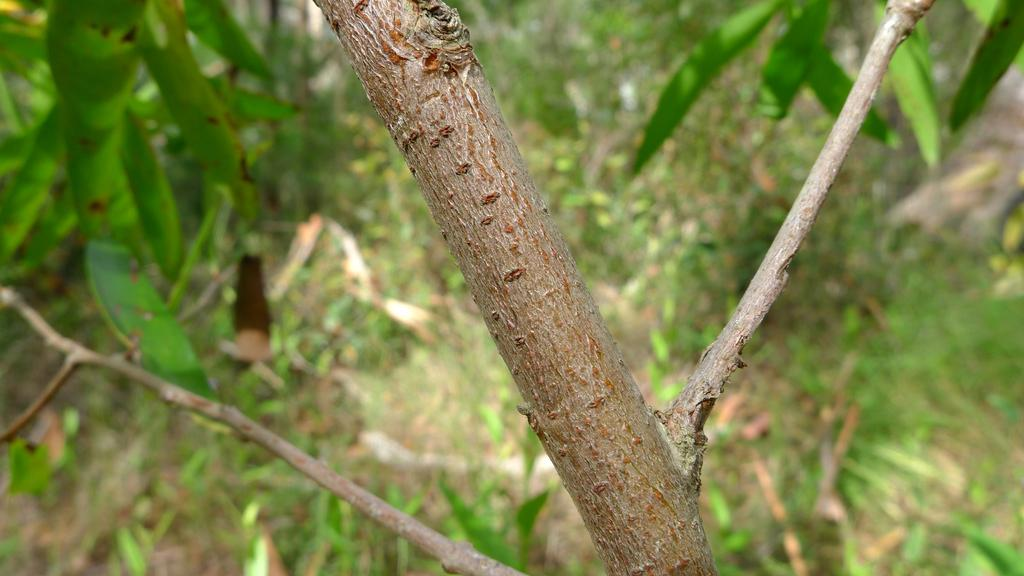What is in the foreground of the image? There is a tree branch and stems in the foreground of the image. What is visible in the background of the image? There are leaves in the background of the image. What type of boat can be seen in the aftermath of the storm in the image? There is no boat or storm present in the image; it features a tree branch and stems in the foreground and leaves in the background. 